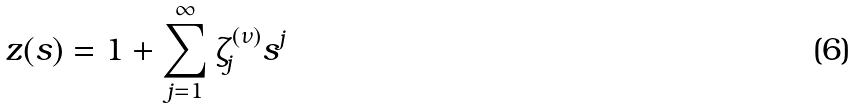Convert formula to latex. <formula><loc_0><loc_0><loc_500><loc_500>z ( s ) = 1 + \sum _ { j = 1 } ^ { \infty } \zeta _ { j } ^ { ( \nu ) } s ^ { j }</formula> 